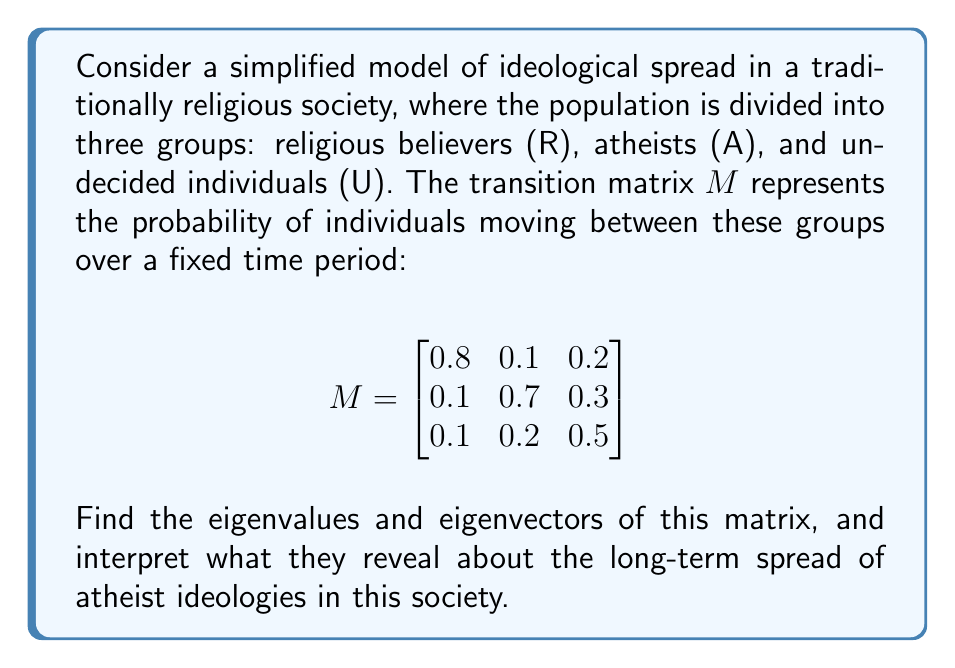Teach me how to tackle this problem. To solve this problem, we'll follow these steps:

1. Find the characteristic equation of the matrix
2. Solve for the eigenvalues
3. Find the corresponding eigenvectors
4. Interpret the results

Step 1: Characteristic equation

The characteristic equation is given by $\det(M - \lambda I) = 0$, where $I$ is the 3x3 identity matrix.

$$\det\begin{pmatrix}
0.8-\lambda & 0.1 & 0.2 \\
0.1 & 0.7-\lambda & 0.3 \\
0.1 & 0.2 & 0.5-\lambda
\end{pmatrix} = 0$$

Expanding this determinant:

$$(0.8-\lambda)[(0.7-\lambda)(0.5-\lambda)-0.06] - 0.1[0.1(0.5-\lambda)-0.06] + 0.2[0.1(0.7-\lambda)-0.03] = 0$$

Simplifying:

$$-\lambda^3 + 2\lambda^2 - 1.09\lambda + 0.18 = 0$$

Step 2: Solve for eigenvalues

Using a numerical method or computer algebra system, we find the eigenvalues:

$\lambda_1 = 1$, $\lambda_2 \approx 0.6728$, $\lambda_3 \approx 0.3272$

Step 3: Find eigenvectors

For $\lambda_1 = 1$:
Solving $(M - I)\mathbf{v}_1 = \mathbf{0}$, we get:
$\mathbf{v}_1 \approx (0.4000, 0.4000, 0.2000)^T$

For $\lambda_2 \approx 0.6728$:
$\mathbf{v}_2 \approx (0.7040, -0.6392, -0.3089)^T$

For $\lambda_3 \approx 0.3272$:
$\mathbf{v}_3 \approx (0.1294, -0.2181, 0.9673)^T$

Step 4: Interpretation

The eigenvalue $\lambda_1 = 1$ corresponds to the steady-state distribution. The associated eigenvector $\mathbf{v}_1$ indicates that in the long run, the population will stabilize at approximately 40% religious, 40% atheist, and 20% undecided.

The other eigenvalues ($\lambda_2$ and $\lambda_3$) are less than 1, indicating that their associated eigenvectors represent transient behaviors that will decay over time. The larger eigenvalue ($\lambda_2$) corresponds to a slower-decaying mode, while the smaller eigenvalue ($\lambda_3$) represents a faster-decaying mode.

The eigenvector $\mathbf{v}_2$ shows a contrast between religious believers and atheists, suggesting that fluctuations between these two groups will persist longer than other transient behaviors.

The eigenvector $\mathbf{v}_3$ primarily represents fluctuations in the undecided group, which will decay more rapidly.
Answer: Eigenvalues: $\lambda_1 = 1$, $\lambda_2 \approx 0.6728$, $\lambda_3 \approx 0.3272$

Eigenvectors:
$\mathbf{v}_1 \approx (0.4000, 0.4000, 0.2000)^T$
$\mathbf{v}_2 \approx (0.7040, -0.6392, -0.3089)^T$
$\mathbf{v}_3 \approx (0.1294, -0.2181, 0.9673)^T$

Interpretation: The long-term steady-state distribution is approximately 40% religious, 40% atheist, and 20% undecided. Fluctuations between religious and atheist groups will persist longer than other transient behaviors, while fluctuations in the undecided group will decay more rapidly. 